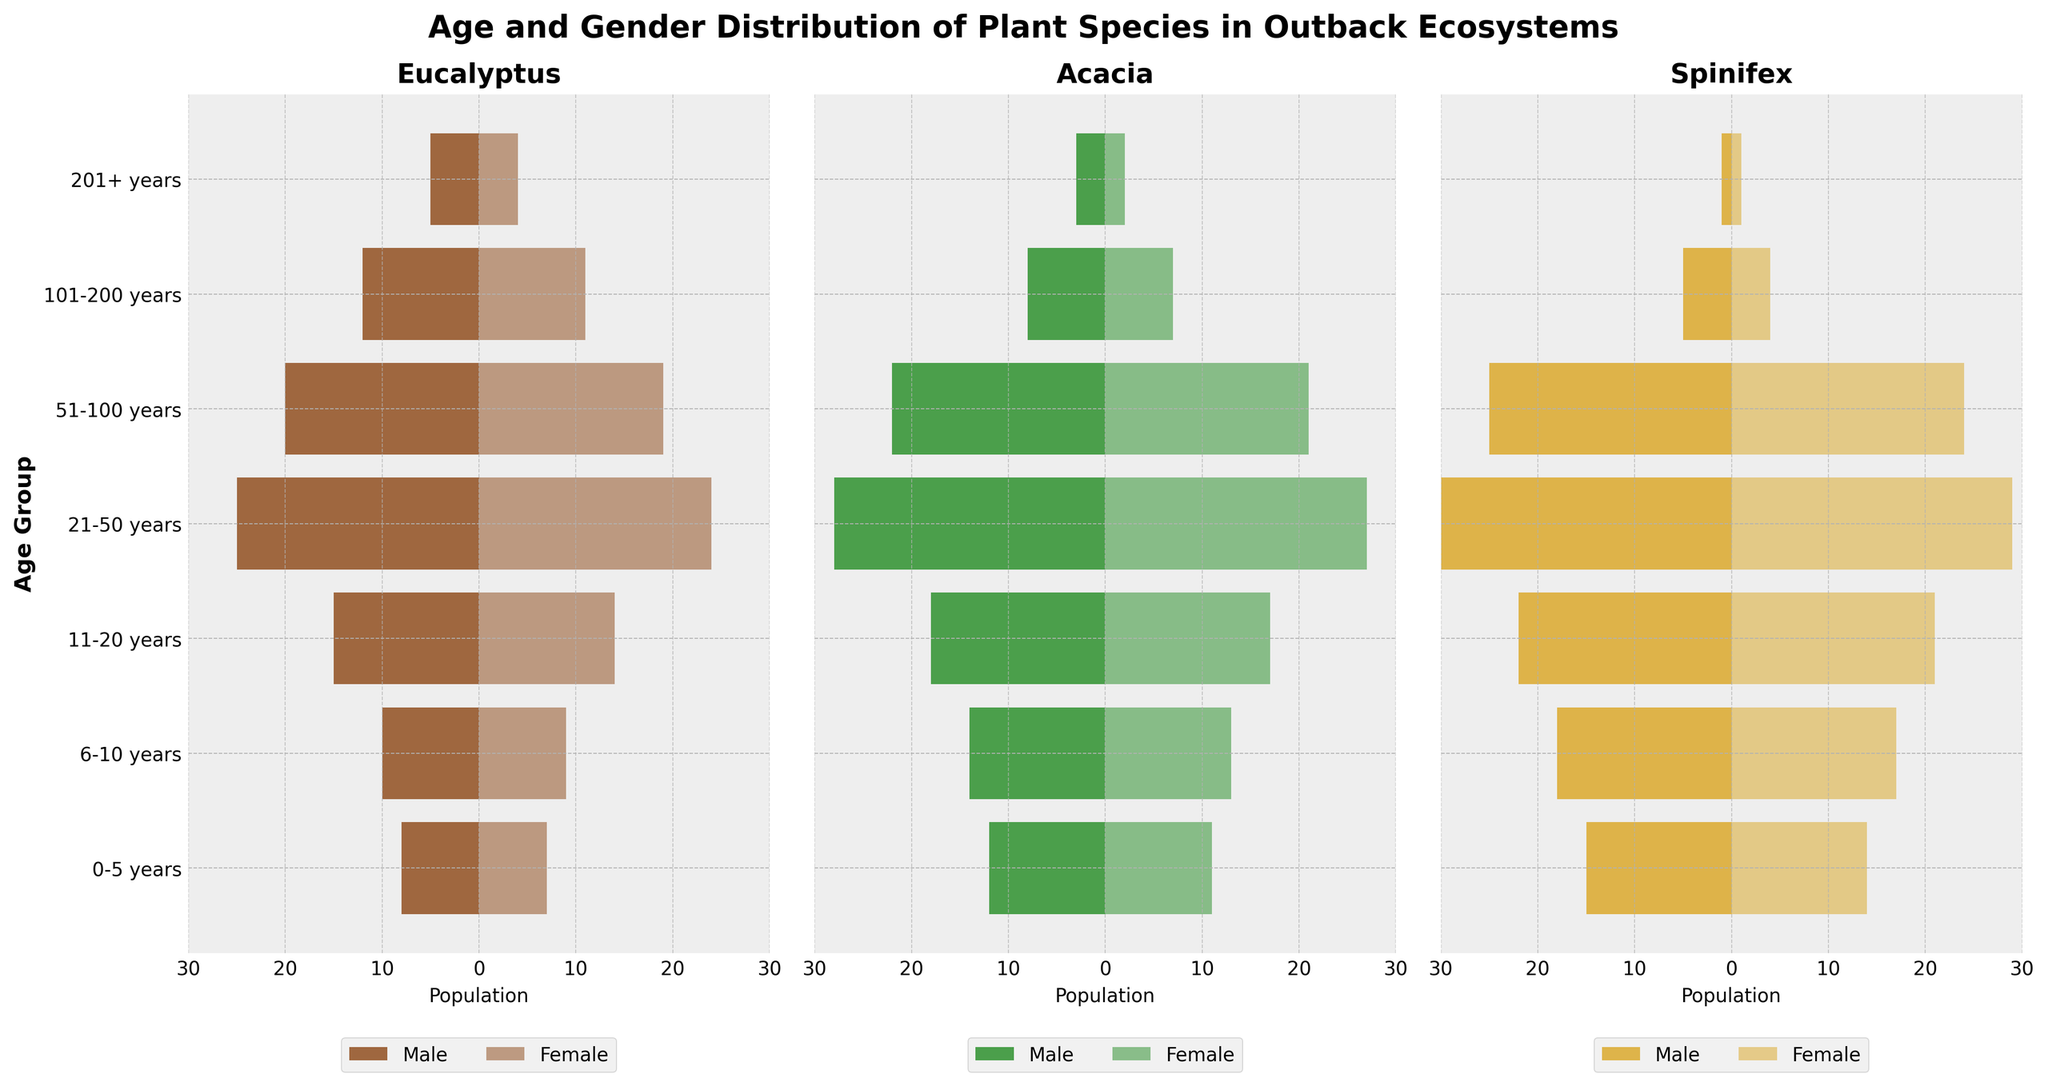What are the age groups shown on the y-axis? The age groups listed on the y-axis are 0-5 years, 6-10 years, 11-20 years, 21-50 years, 51-100 years, 101-200 years, and 201+ years. These can be directly read from the y-axis labels.
Answer: 0-5 years, 6-10 years, 11-20 years, 21-50 years, 51-100 years, 101-200 years, 201+ years What does the title of the figure indicate? The title states "Age and Gender Distribution of Plant Species in Outback Ecosystems". This indicates that the plot represents how different age groups and genders are distributed among plant species in Outback ecosystems.
Answer: Age and Gender Distribution of Plant Species in Outback Ecosystems Which species has the highest number of individuals in the age group 21-50 years? By looking at the bars for the 21-50 years age group, Spinifex has the highest combined number of males and females.
Answer: Spinifex How many female Acacia plants are there in the 101-200 years age group? By looking at the female bars for Acacia in the 101-200 years age group, we see that there are 7 female plants.
Answer: 7 Compare the number of male Eucalyptus plants in the 6-10 years age group to the number of female Spinifex plants in the same age group. Which one has more? The number of male Eucalyptus plants in the 6-10 years age group is 10 while the number of female Spinifex plants in the same age group is 17. Therefore, female Spinifex plants are more.
Answer: Female Spinifex plants Which age group has a higher count of male Eucalyptus plants: 0-5 years or 201+ years? Comparing the male Eucalyptus plants in 0-5 years (8 plants) and 201+ years (5 plants), the 0-5 years age group has a higher count.
Answer: 0-5 years What is the sum of female plants across all age groups for Acacia? Sum the number of female Acacia plants across all age groups: 11 + 13 + 17 + 27 + 21 + 7 + 2 = 98.
Answer: 98 In which age group is the population distribution of both male and female Spinifex plants similar? In the 0-5 years age group, male Spinifex plants are 15 and female Spinifex plants are 14, showing similar distribution.
Answer: 0-5 years What age group shows the largest difference between the number of male and female Eucalyptus plants? Calculating the difference for each age group, 0-5 years: 1, 6-10 years: 1, 11-20 years: 1, 21-50 years: 1, 51-100 years: 1, 101-200 years: 1, 201+ years: 1. The figure doesn't show any substantial differences beyond 1 in any age groups.
Answer: None, differences are all 1 For the Acacia species, which gender shows a decrease in population from the 51-100 years age group to the 101-200 years age group, and by how much? From 51-100 years to 101-200 years, male Acacia decrease from 22 to 8, a difference of 14. Female Acacia decreases from 21 to 7, a difference of 14. Both genders decrease.
Answer: Both, by 14 